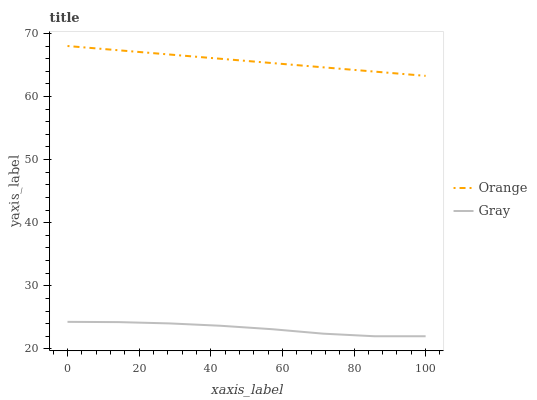Does Gray have the minimum area under the curve?
Answer yes or no. Yes. Does Orange have the maximum area under the curve?
Answer yes or no. Yes. Does Gray have the maximum area under the curve?
Answer yes or no. No. Is Orange the smoothest?
Answer yes or no. Yes. Is Gray the roughest?
Answer yes or no. Yes. Is Gray the smoothest?
Answer yes or no. No. Does Orange have the highest value?
Answer yes or no. Yes. Does Gray have the highest value?
Answer yes or no. No. Is Gray less than Orange?
Answer yes or no. Yes. Is Orange greater than Gray?
Answer yes or no. Yes. Does Gray intersect Orange?
Answer yes or no. No. 